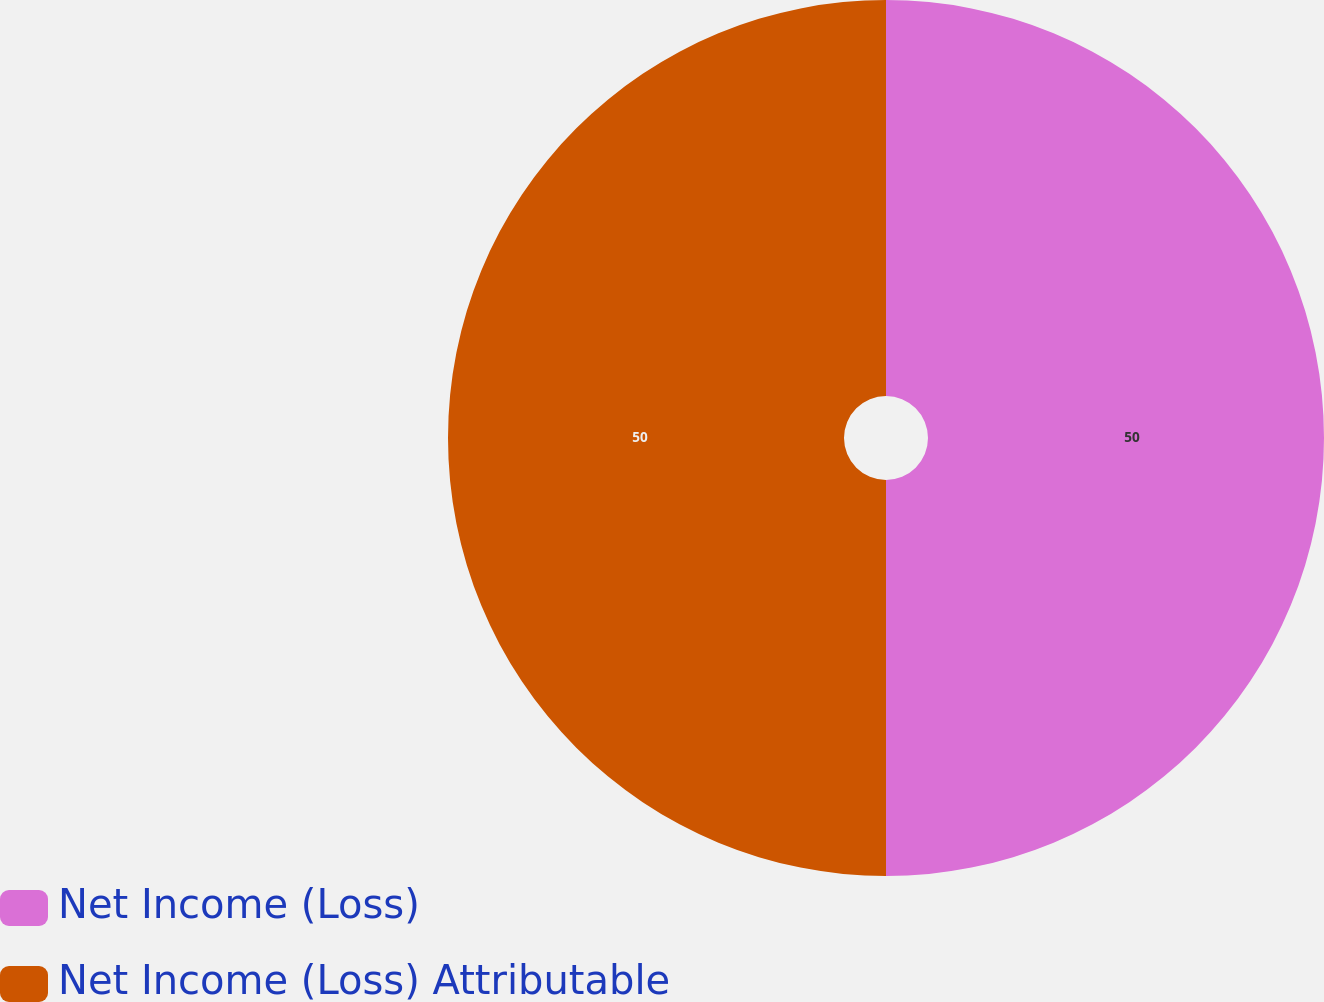Convert chart to OTSL. <chart><loc_0><loc_0><loc_500><loc_500><pie_chart><fcel>Net Income (Loss)<fcel>Net Income (Loss) Attributable<nl><fcel>50.0%<fcel>50.0%<nl></chart> 